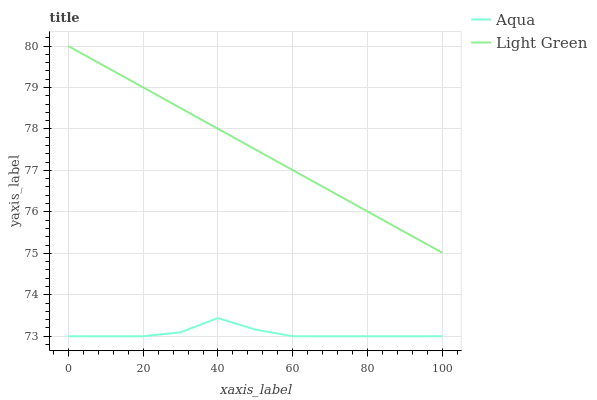Does Light Green have the minimum area under the curve?
Answer yes or no. No. Is Light Green the roughest?
Answer yes or no. No. Does Light Green have the lowest value?
Answer yes or no. No. Is Aqua less than Light Green?
Answer yes or no. Yes. Is Light Green greater than Aqua?
Answer yes or no. Yes. Does Aqua intersect Light Green?
Answer yes or no. No. 